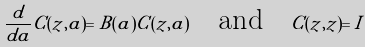Convert formula to latex. <formula><loc_0><loc_0><loc_500><loc_500>\frac { d } { d a } C ( z , a ) = B ( a ) C ( z , a ) \quad \text {and} \quad C ( z , z ) = I</formula> 